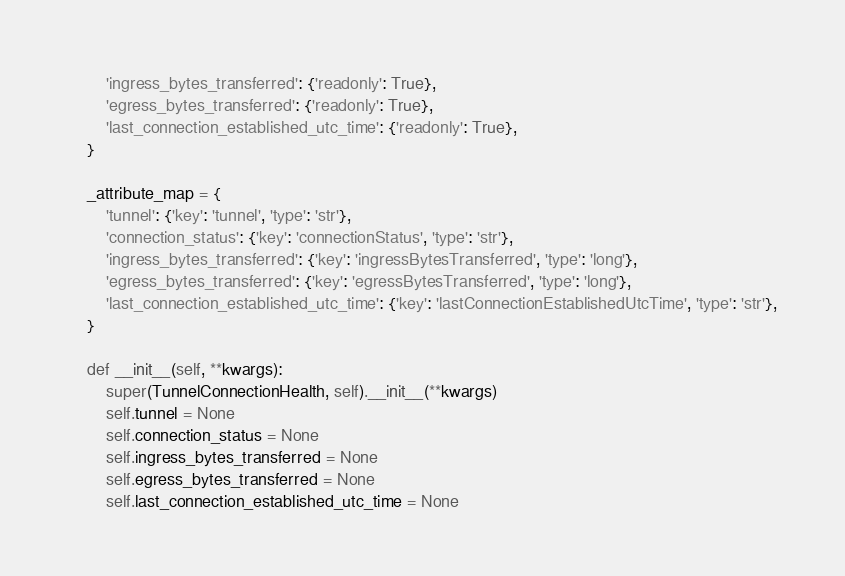<code> <loc_0><loc_0><loc_500><loc_500><_Python_>        'ingress_bytes_transferred': {'readonly': True},
        'egress_bytes_transferred': {'readonly': True},
        'last_connection_established_utc_time': {'readonly': True},
    }

    _attribute_map = {
        'tunnel': {'key': 'tunnel', 'type': 'str'},
        'connection_status': {'key': 'connectionStatus', 'type': 'str'},
        'ingress_bytes_transferred': {'key': 'ingressBytesTransferred', 'type': 'long'},
        'egress_bytes_transferred': {'key': 'egressBytesTransferred', 'type': 'long'},
        'last_connection_established_utc_time': {'key': 'lastConnectionEstablishedUtcTime', 'type': 'str'},
    }

    def __init__(self, **kwargs):
        super(TunnelConnectionHealth, self).__init__(**kwargs)
        self.tunnel = None
        self.connection_status = None
        self.ingress_bytes_transferred = None
        self.egress_bytes_transferred = None
        self.last_connection_established_utc_time = None
</code> 